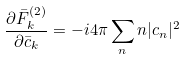Convert formula to latex. <formula><loc_0><loc_0><loc_500><loc_500>\frac { \partial \bar { F } ^ { ( 2 ) } _ { k } } { \partial \bar { c } _ { k } } = - i 4 \pi \sum _ { n } n | c _ { n } | ^ { 2 }</formula> 